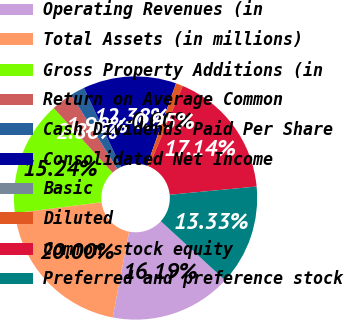<chart> <loc_0><loc_0><loc_500><loc_500><pie_chart><fcel>Operating Revenues (in<fcel>Total Assets (in millions)<fcel>Gross Property Additions (in<fcel>Return on Average Common<fcel>Cash Dividends Paid Per Share<fcel>Consolidated Net Income<fcel>Basic<fcel>Diluted<fcel>Common stock equity<fcel>Preferred and preference stock<nl><fcel>16.19%<fcel>20.0%<fcel>15.24%<fcel>2.86%<fcel>1.9%<fcel>12.38%<fcel>0.0%<fcel>0.95%<fcel>17.14%<fcel>13.33%<nl></chart> 